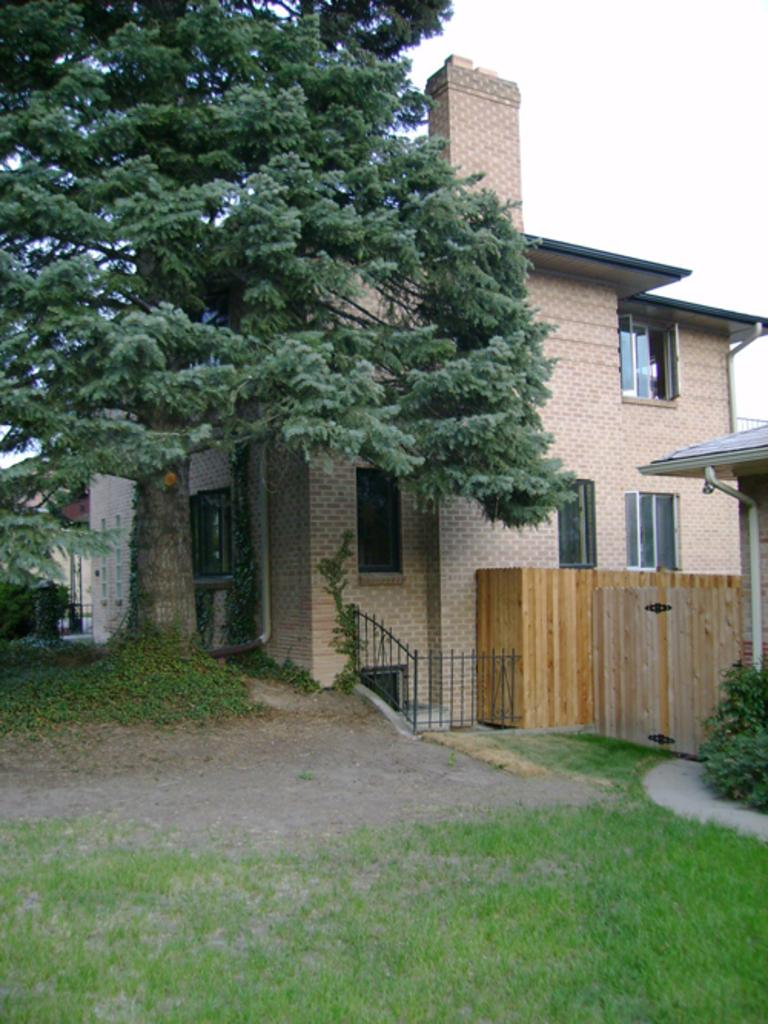What type of structure is visible in the image? There is a building in the image. What natural element is present in the image? There is a tree in the image. What type of barrier can be seen in the image? There is a fence in the image. What type of vegetation is present in the image? There are plants in the image. What other objects can be seen in the image? There are other objects in the image. What part of the sky is visible in the image? The sky is visible at the top right side of the image. What type of ground cover is present at the bottom of the image? Grass is present at the bottom of the image. What type of potato is being used as a positioning tool in the image? There is no potato present in the image, nor is there any indication of a positioning tool being used. 